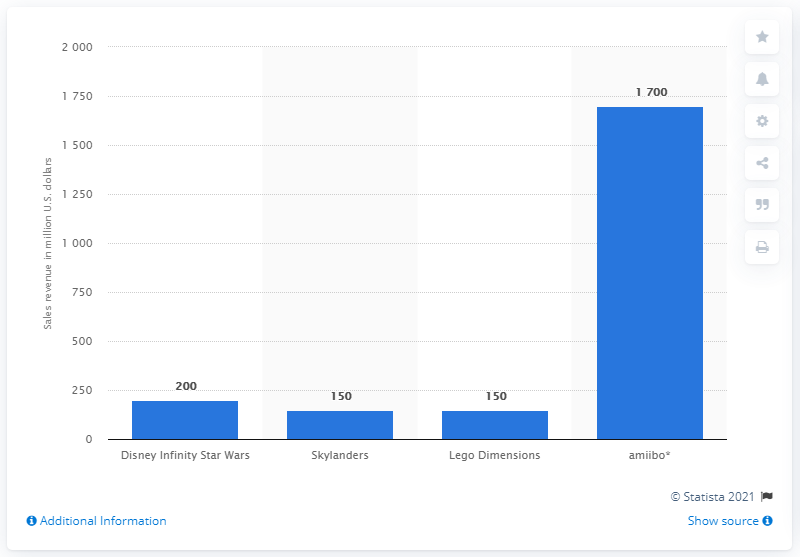Draw attention to some important aspects in this diagram. Disney Infinity 3.0 sold approximately 200 units of merchandise worth a total of dollars. 